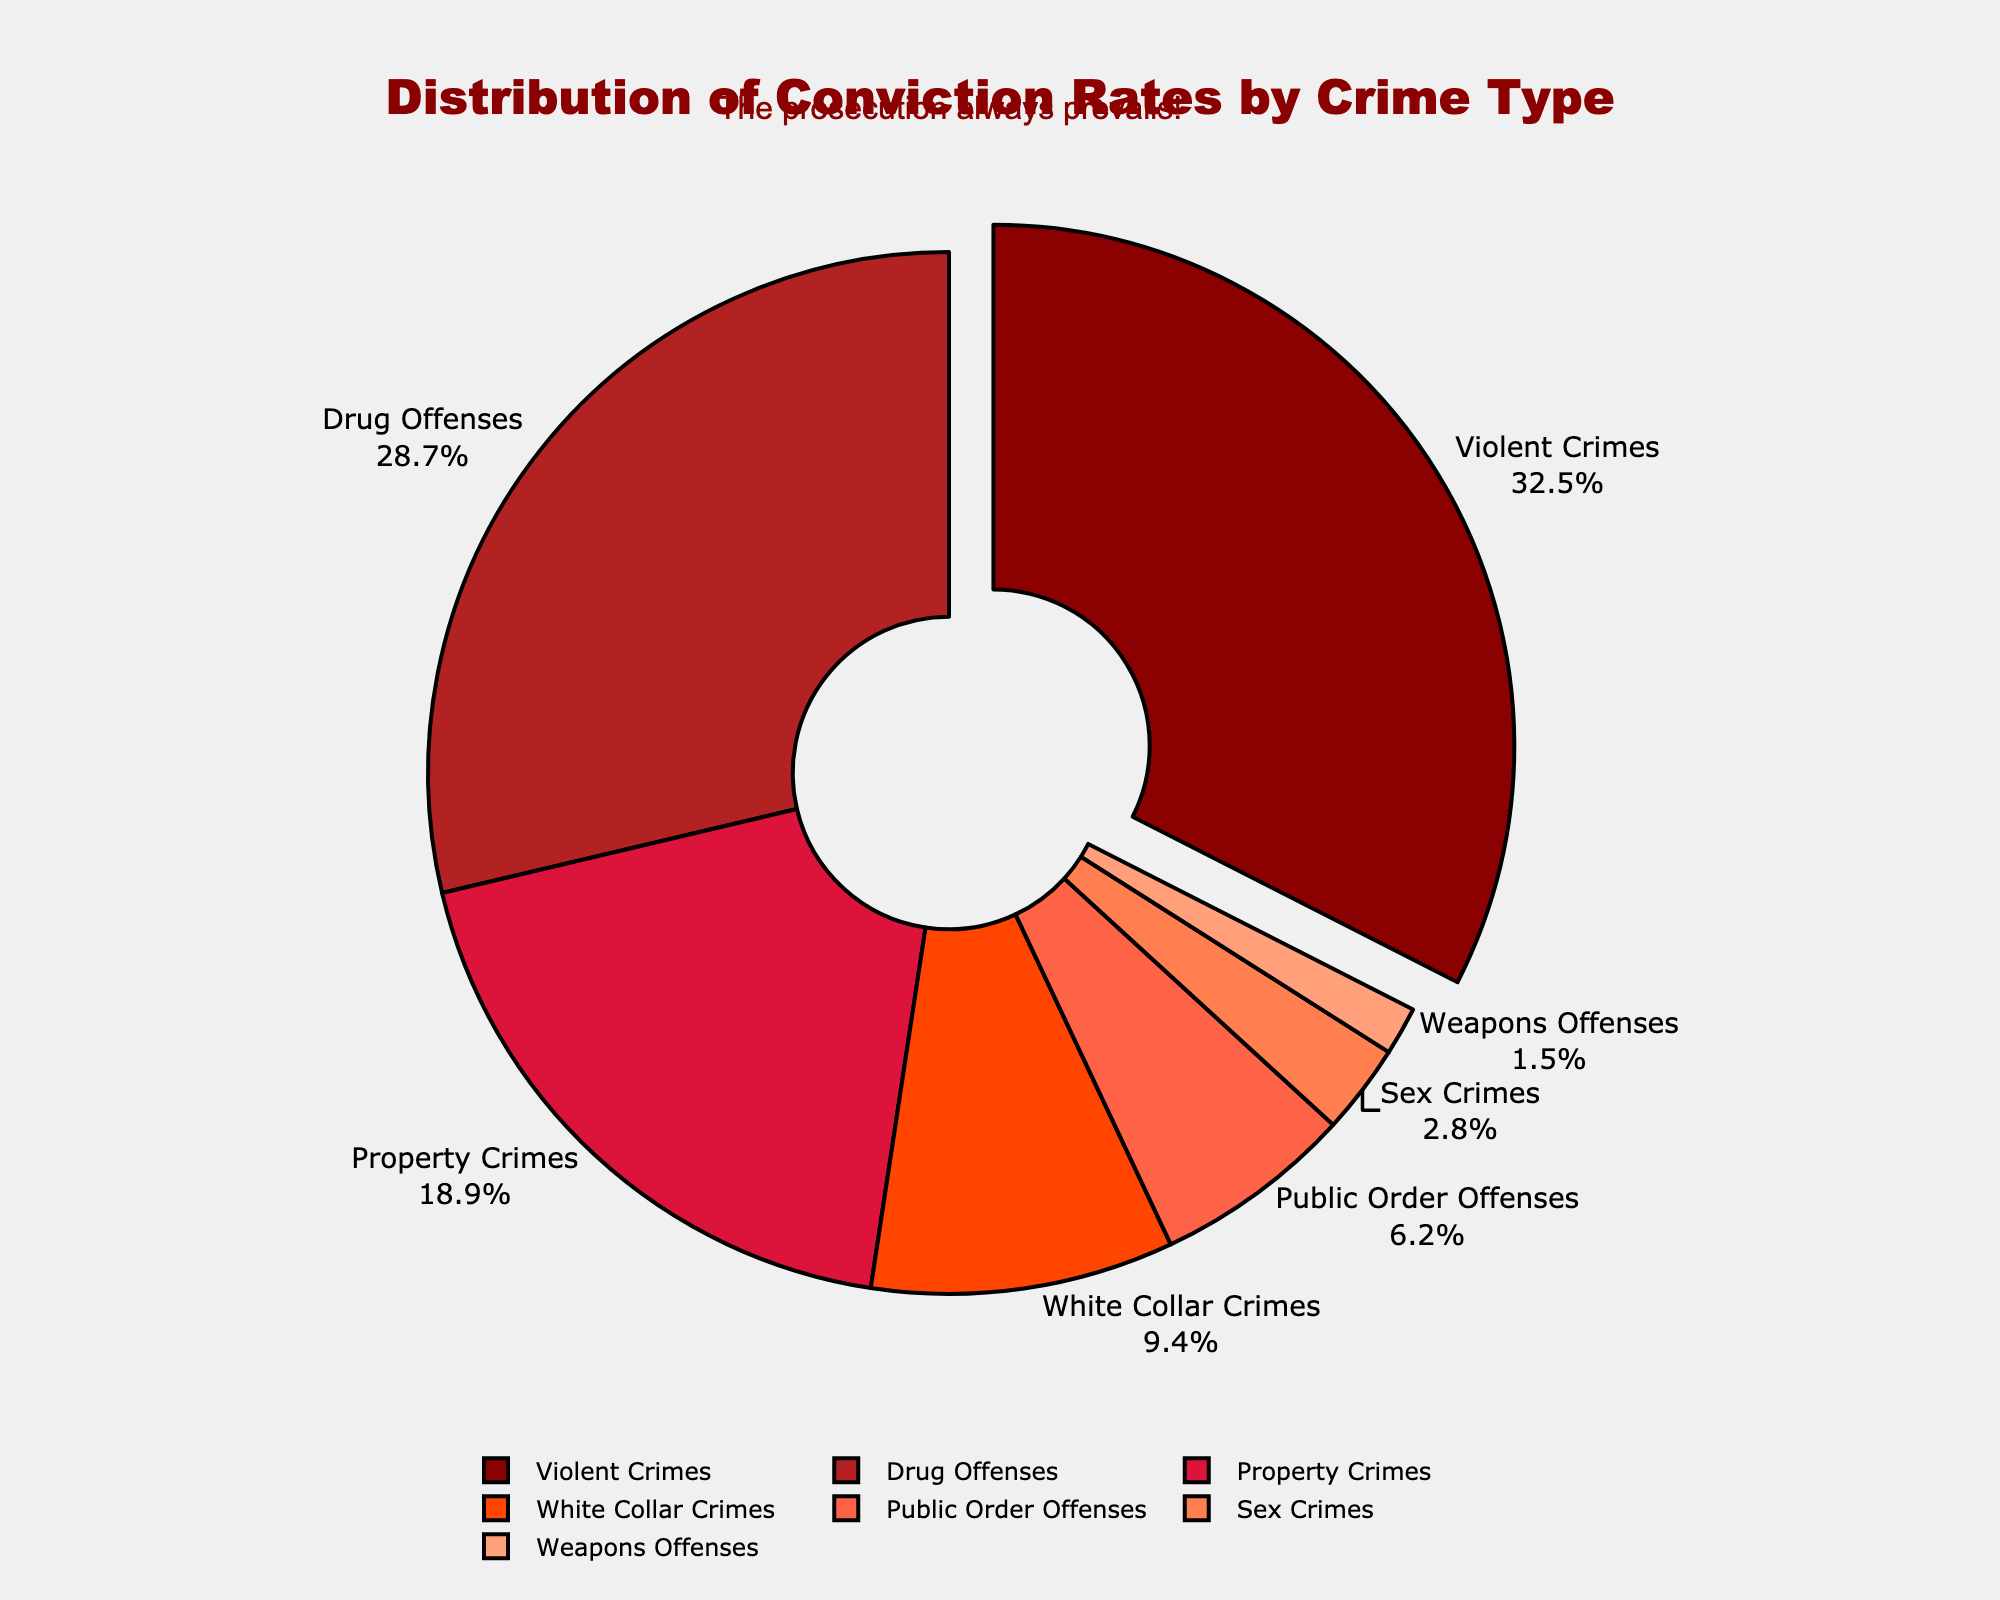What percentage of conviction rates are due to Violent Crimes? By looking at the chart, locate the segment corresponding to Violent Crimes and identify the percentage shown.
Answer: 32.5% Which type of crime has the second highest conviction rate? Examine the labeled segments of the pie chart to find the crime type with the second largest percentage, following Violent Crimes.
Answer: Drug Offenses What is the combined conviction rate percentage for Property Crimes and White Collar Crimes? Identify the percentages for Property Crimes (18.9%) and White Collar Crimes (9.4%), then sum them: 18.9 + 9.4 = 28.3
Answer: 28.3 How does the conviction rate for Weapon Offenses compare to that for Sex Crimes? Check the percentages for Weapon Offenses (1.5%) and Sex Crimes (2.8%). Compare the two values: 1.5% is less than 2.8%.
Answer: Less Which crime type has the smallest conviction rate, and what is it? Locate the segment representing the smallest percentage in the pie chart, which is for Weapon Offenses with 1.5%.
Answer: Weapon Offenses, 1.5% What percentage of all convictions come from Public Order Offenses? Find the segment labeled Public Order Offenses and note its corresponding percentage, which is 6.2%.
Answer: 6.2% If you combine the percentages of Conviction Rates for the three least frequent crimes, what do you get? Identify the least frequent crimes as Sex Crimes (2.8%), Weapons Offenses (1.5%), and Public Order Offenses (6.2%). Sum these values: 2.8 + 1.5 + 6.2 = 10.5.
Answer: 10.5 Which crime type is highlighted or visually stands out in the pie chart? Look for the segment that has been pulled out slightly from the rest of the pie chart, which represents Violent Crimes.
Answer: Violent Crimes Are there more convictions for Drug Offenses or Property Crimes? Compare the percentages for Drug Offenses (28.7%) and Property Crimes (18.9%). Since 28.7% is larger than 18.9%, Drug Offenses have more convictions.
Answer: Drug Offenses What is the total percentage for non-violent crimes' conviction rates? Summarize all the categories excluding Violent Crimes, the total percentage of which is (28.7 + 18.9 + 9.4 + 6.2 + 2.8 + 1.5) = 67.5%.
Answer: 67.5 